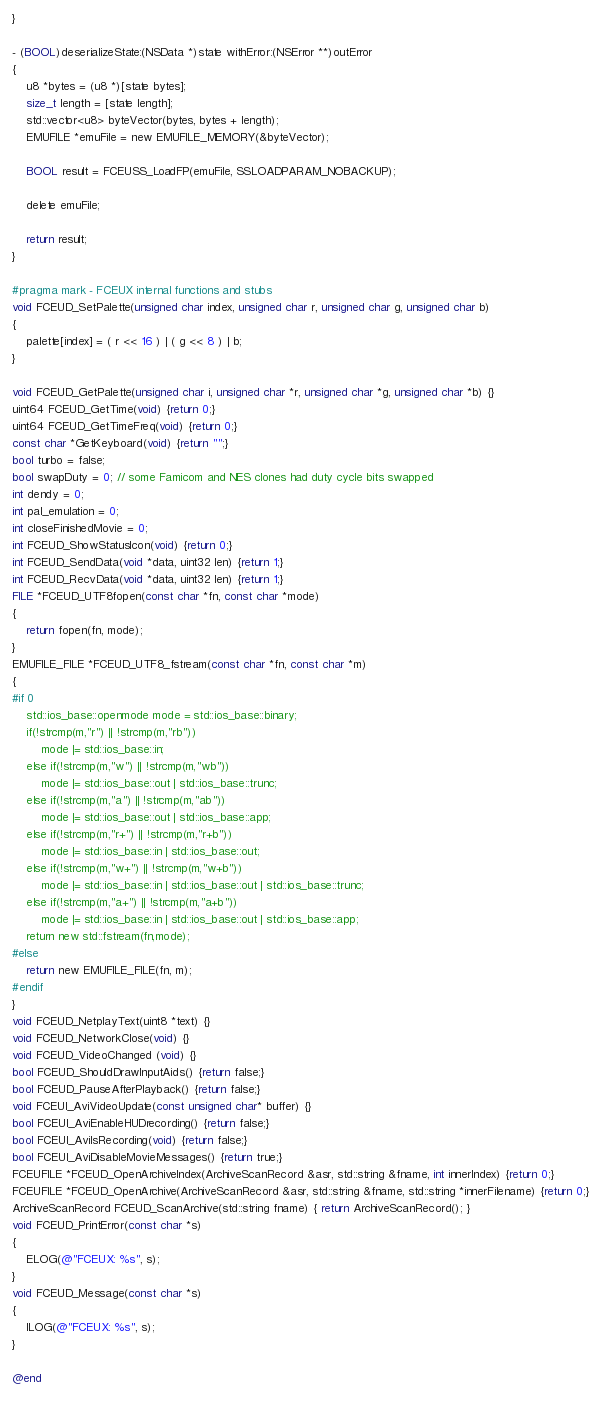<code> <loc_0><loc_0><loc_500><loc_500><_ObjectiveC_>}

- (BOOL)deserializeState:(NSData *)state withError:(NSError **)outError
{
    u8 *bytes = (u8 *)[state bytes];
    size_t length = [state length];
    std::vector<u8> byteVector(bytes, bytes + length);
    EMUFILE *emuFile = new EMUFILE_MEMORY(&byteVector);
    
    BOOL result = FCEUSS_LoadFP(emuFile, SSLOADPARAM_NOBACKUP);
    
    delete emuFile;
    
    return result;
}

#pragma mark - FCEUX internal functions and stubs
void FCEUD_SetPalette(unsigned char index, unsigned char r, unsigned char g, unsigned char b)
{
    palette[index] = ( r << 16 ) | ( g << 8 ) | b;
}

void FCEUD_GetPalette(unsigned char i, unsigned char *r, unsigned char *g, unsigned char *b) {}
uint64 FCEUD_GetTime(void) {return 0;}
uint64 FCEUD_GetTimeFreq(void) {return 0;}
const char *GetKeyboard(void) {return "";}
bool turbo = false;
bool swapDuty = 0; // some Famicom and NES clones had duty cycle bits swapped
int dendy = 0;
int pal_emulation = 0;
int closeFinishedMovie = 0;
int FCEUD_ShowStatusIcon(void) {return 0;}
int FCEUD_SendData(void *data, uint32 len) {return 1;}
int FCEUD_RecvData(void *data, uint32 len) {return 1;}
FILE *FCEUD_UTF8fopen(const char *fn, const char *mode)
{
    return fopen(fn, mode);
}
EMUFILE_FILE *FCEUD_UTF8_fstream(const char *fn, const char *m)
{
#if 0
	std::ios_base::openmode mode = std::ios_base::binary;
    if(!strcmp(m,"r") || !strcmp(m,"rb"))
        mode |= std::ios_base::in;
    else if(!strcmp(m,"w") || !strcmp(m,"wb"))
        mode |= std::ios_base::out | std::ios_base::trunc;
    else if(!strcmp(m,"a") || !strcmp(m,"ab"))
        mode |= std::ios_base::out | std::ios_base::app;
    else if(!strcmp(m,"r+") || !strcmp(m,"r+b"))
        mode |= std::ios_base::in | std::ios_base::out;
    else if(!strcmp(m,"w+") || !strcmp(m,"w+b"))
        mode |= std::ios_base::in | std::ios_base::out | std::ios_base::trunc;
    else if(!strcmp(m,"a+") || !strcmp(m,"a+b"))
        mode |= std::ios_base::in | std::ios_base::out | std::ios_base::app;
	return new std::fstream(fn,mode);
#else
    return new EMUFILE_FILE(fn, m);
#endif
}
void FCEUD_NetplayText(uint8 *text) {}
void FCEUD_NetworkClose(void) {}
void FCEUD_VideoChanged (void) {}
bool FCEUD_ShouldDrawInputAids() {return false;}
bool FCEUD_PauseAfterPlayback() {return false;}
void FCEUI_AviVideoUpdate(const unsigned char* buffer) {}
bool FCEUI_AviEnableHUDrecording() {return false;}
bool FCEUI_AviIsRecording(void) {return false;}
bool FCEUI_AviDisableMovieMessages() {return true;}
FCEUFILE *FCEUD_OpenArchiveIndex(ArchiveScanRecord &asr, std::string &fname, int innerIndex) {return 0;}
FCEUFILE *FCEUD_OpenArchive(ArchiveScanRecord &asr, std::string &fname, std::string *innerFilename) {return 0;}
ArchiveScanRecord FCEUD_ScanArchive(std::string fname) { return ArchiveScanRecord(); }
void FCEUD_PrintError(const char *s)
{
    ELOG(@"FCEUX: %s", s);
}
void FCEUD_Message(const char *s)
{
    ILOG(@"FCEUX: %s", s);
}

@end
</code> 